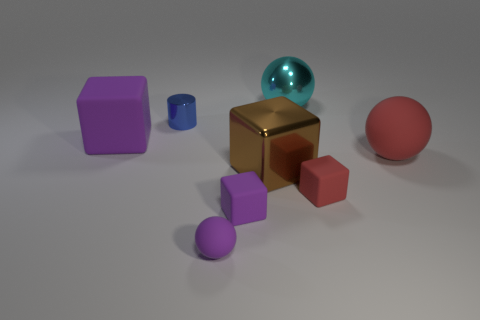There is a cube that is the same color as the large matte ball; what is it made of?
Offer a very short reply. Rubber. Are there any purple objects that have the same shape as the big brown thing?
Ensure brevity in your answer.  Yes. How many small purple objects have the same shape as the brown object?
Make the answer very short. 1. Is the color of the small sphere the same as the large matte cube?
Provide a short and direct response. Yes. Are there fewer large red shiny things than brown metal things?
Provide a succinct answer. Yes. What material is the large brown object that is on the right side of the blue metallic object?
Offer a terse response. Metal. What is the material of the purple block that is the same size as the red sphere?
Provide a succinct answer. Rubber. What material is the small block to the left of the big metal thing that is behind the purple cube behind the brown cube made of?
Keep it short and to the point. Rubber. Is the size of the sphere that is on the right side of the cyan sphere the same as the tiny red thing?
Your answer should be compact. No. Are there more green cubes than large objects?
Give a very brief answer. No. 